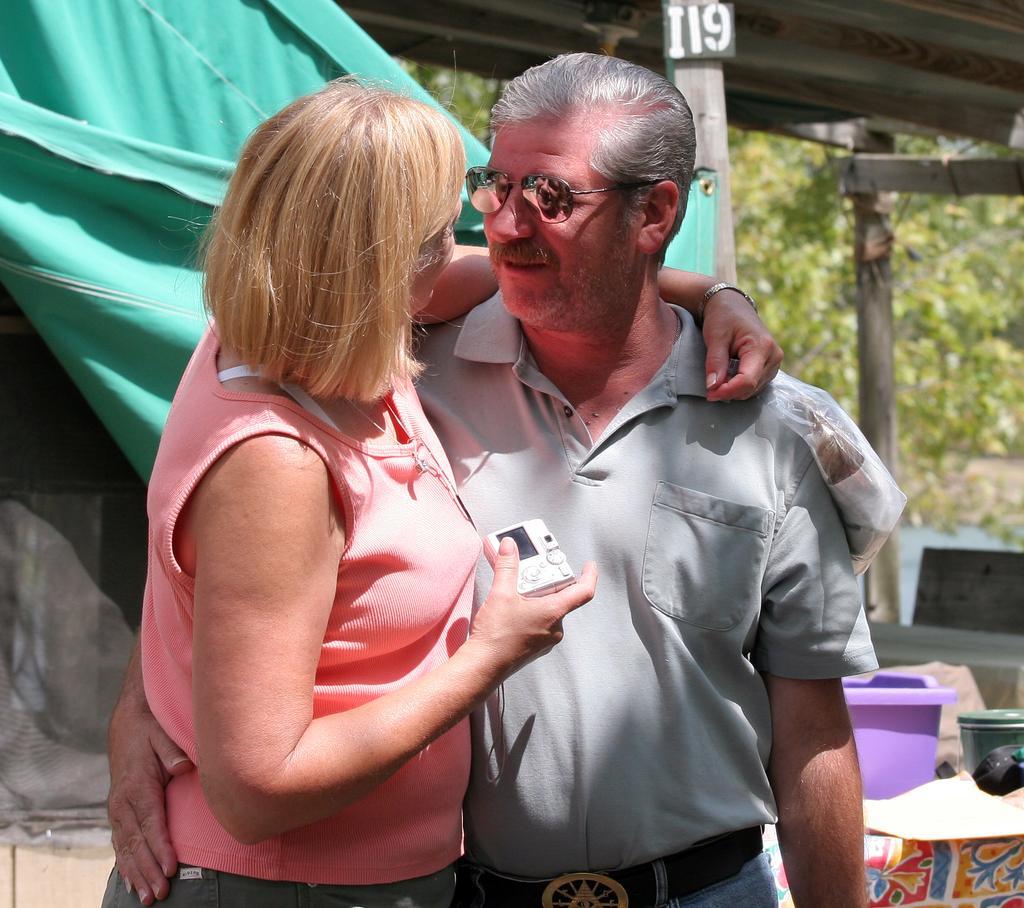Could you give a brief overview of what you see in this image? Here I can see a woman and a man are holding each other, standing and looking at each other. The woman is holding a camera in a hand. On the right side there is a tub and some other objects. In the background there is a cloth, shed and some trees. 